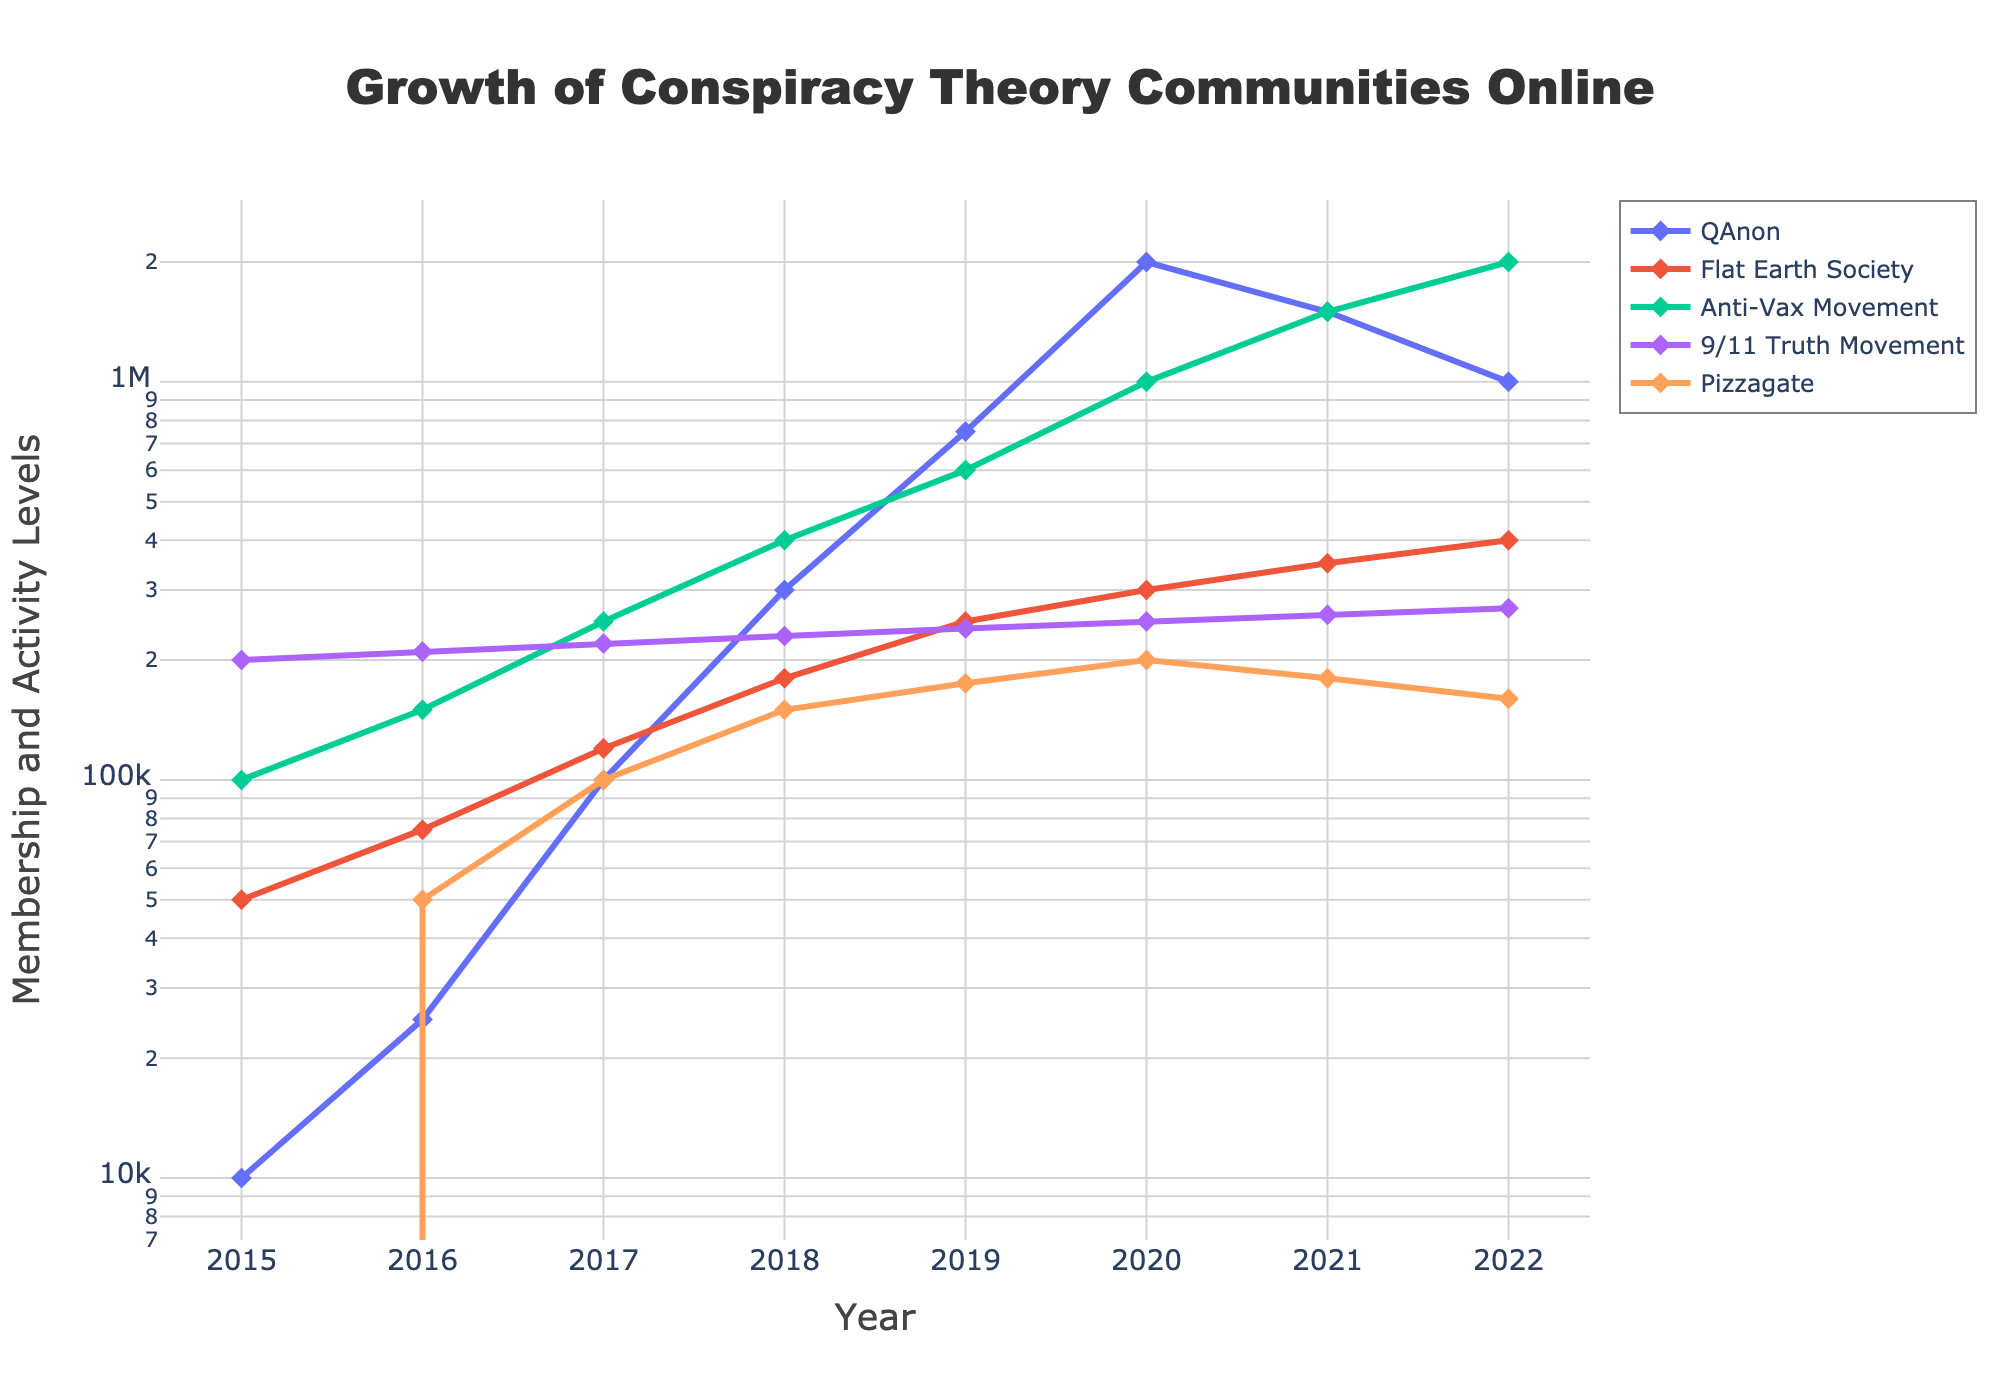What is the overall growth of the QAnon community from 2015 to 2022? Look at the chart and identify the membership numbers for QAnon in 2015 (10,000) and in 2022 (1,000,000). Calculate the difference by subtracting the 2015 value from the 2022 value: 1,000,000 - 10,000 = 990,000.
Answer: 990,000 Which conspiracy theory community had the highest membership in 2020? Observe the lines and markers for the year 2020 and identify which community's value is the highest. QAnon had the highest value at 2,000,000.
Answer: QAnon What is the average membership for the Flat Earth Society between 2015 and 2019? Aggregate the membership numbers for the Flat Earth Society from 2015 to 2019: (50,000 + 75,000 + 120,000 + 180,000 + 250,000). Sum them up to get 675,000 and then divide by 5 (the number of years): 675,000 / 5 = 135,000.
Answer: 135,000 How did the overall membership of the Anti-Vax Movement change from 2019 to 2022? Look at the membership values for 2019 (600,000) and 2022 (2,000,000). Calculate the difference: 2,000,000 - 600,000 = 1,400,000.
Answer: 1,400,000 Is there any year where Pizzagate had more membership than the 9/11 Truth Movement? Compare the membership numbers for Pizzagate and the 9/11 Truth Movement for each year. The only year where Pizzagate membership exceeds the 9/11 Truth Movement is in 2020 (200,000 vs 250,000).
Answer: No What is the cumulative membership of all communities in 2016? Add the membership numbers of all communities in 2016: 25,000 (QAnon) + 75,000 (Flat Earth Society) + 150,000 (Anti-Vax) + 210,000 (9/11 Truth Movement) + 50,000 (Pizzagate) = 510,000.
Answer: 510,000 By how much did the 9/11 Truth Movement increase from 2015 to 2022? Look at the membership values for the 9/11 Truth Movement in 2015 (200,000) and in 2022 (270,000). Calculate the difference: 270,000 - 200,000 = 70,000.
Answer: 70,000 Which year saw the largest increase in membership for QAnon? Identify the years with the largest jumps in the QAnon line. The largest increase occurred between 2019 (750,000) and 2020 (2,000,000), which is a difference of 1,250,000.
Answer: 2020 